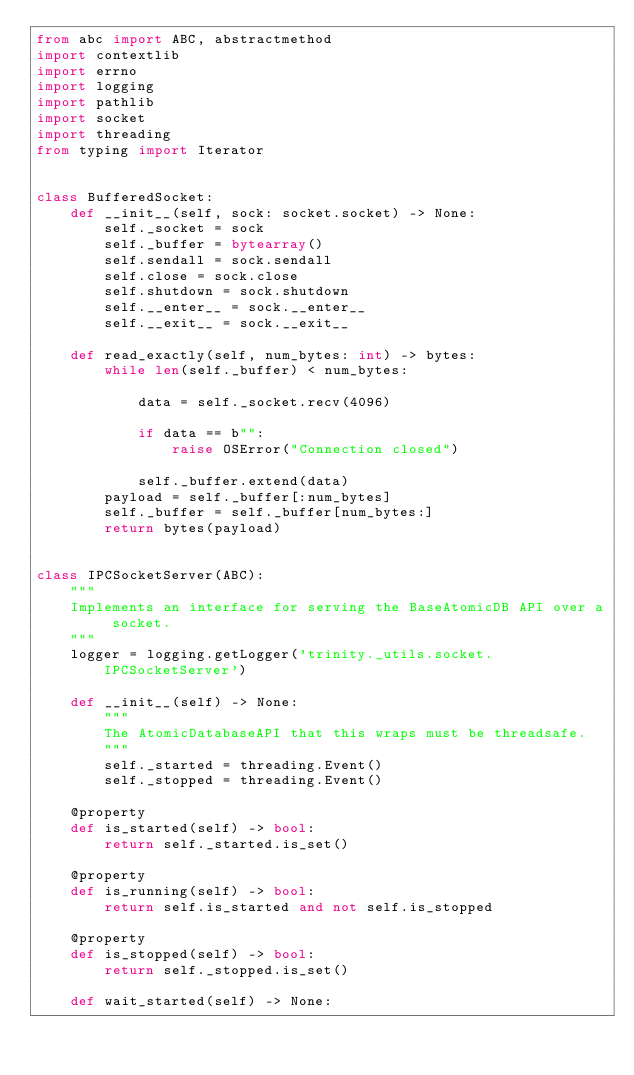Convert code to text. <code><loc_0><loc_0><loc_500><loc_500><_Python_>from abc import ABC, abstractmethod
import contextlib
import errno
import logging
import pathlib
import socket
import threading
from typing import Iterator


class BufferedSocket:
    def __init__(self, sock: socket.socket) -> None:
        self._socket = sock
        self._buffer = bytearray()
        self.sendall = sock.sendall
        self.close = sock.close
        self.shutdown = sock.shutdown
        self.__enter__ = sock.__enter__
        self.__exit__ = sock.__exit__

    def read_exactly(self, num_bytes: int) -> bytes:
        while len(self._buffer) < num_bytes:

            data = self._socket.recv(4096)

            if data == b"":
                raise OSError("Connection closed")

            self._buffer.extend(data)
        payload = self._buffer[:num_bytes]
        self._buffer = self._buffer[num_bytes:]
        return bytes(payload)


class IPCSocketServer(ABC):
    """
    Implements an interface for serving the BaseAtomicDB API over a socket.
    """
    logger = logging.getLogger('trinity._utils.socket.IPCSocketServer')

    def __init__(self) -> None:
        """
        The AtomicDatabaseAPI that this wraps must be threadsafe.
        """
        self._started = threading.Event()
        self._stopped = threading.Event()

    @property
    def is_started(self) -> bool:
        return self._started.is_set()

    @property
    def is_running(self) -> bool:
        return self.is_started and not self.is_stopped

    @property
    def is_stopped(self) -> bool:
        return self._stopped.is_set()

    def wait_started(self) -> None:</code> 